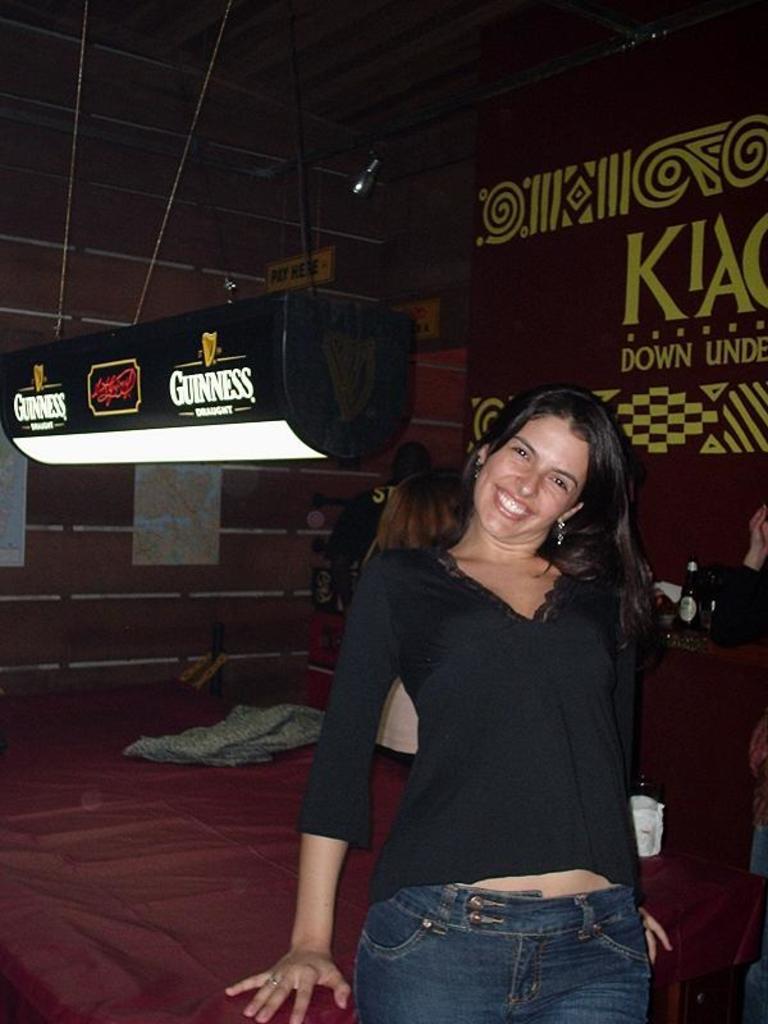Could you give a brief overview of what you see in this image? In this image there is a person sitting on the bed and smiling, and in the background there are group of people standing , bottle and some objects on the table, maps attached to the wall, light, board. 